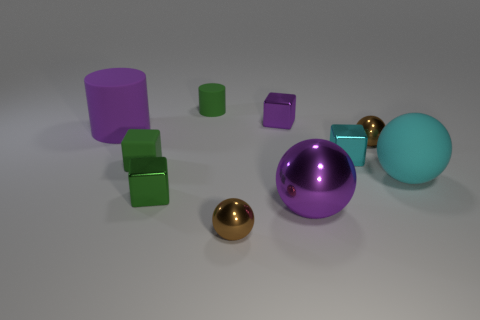Subtract all green cubes. How many brown balls are left? 2 Subtract all large cyan balls. How many balls are left? 3 Subtract all cyan cubes. How many cubes are left? 3 Subtract 1 cylinders. How many cylinders are left? 1 Subtract all spheres. How many objects are left? 6 Subtract all matte blocks. Subtract all green cylinders. How many objects are left? 8 Add 6 balls. How many balls are left? 10 Add 5 tiny green cylinders. How many tiny green cylinders exist? 6 Subtract 0 blue blocks. How many objects are left? 10 Subtract all gray cubes. Subtract all gray spheres. How many cubes are left? 4 